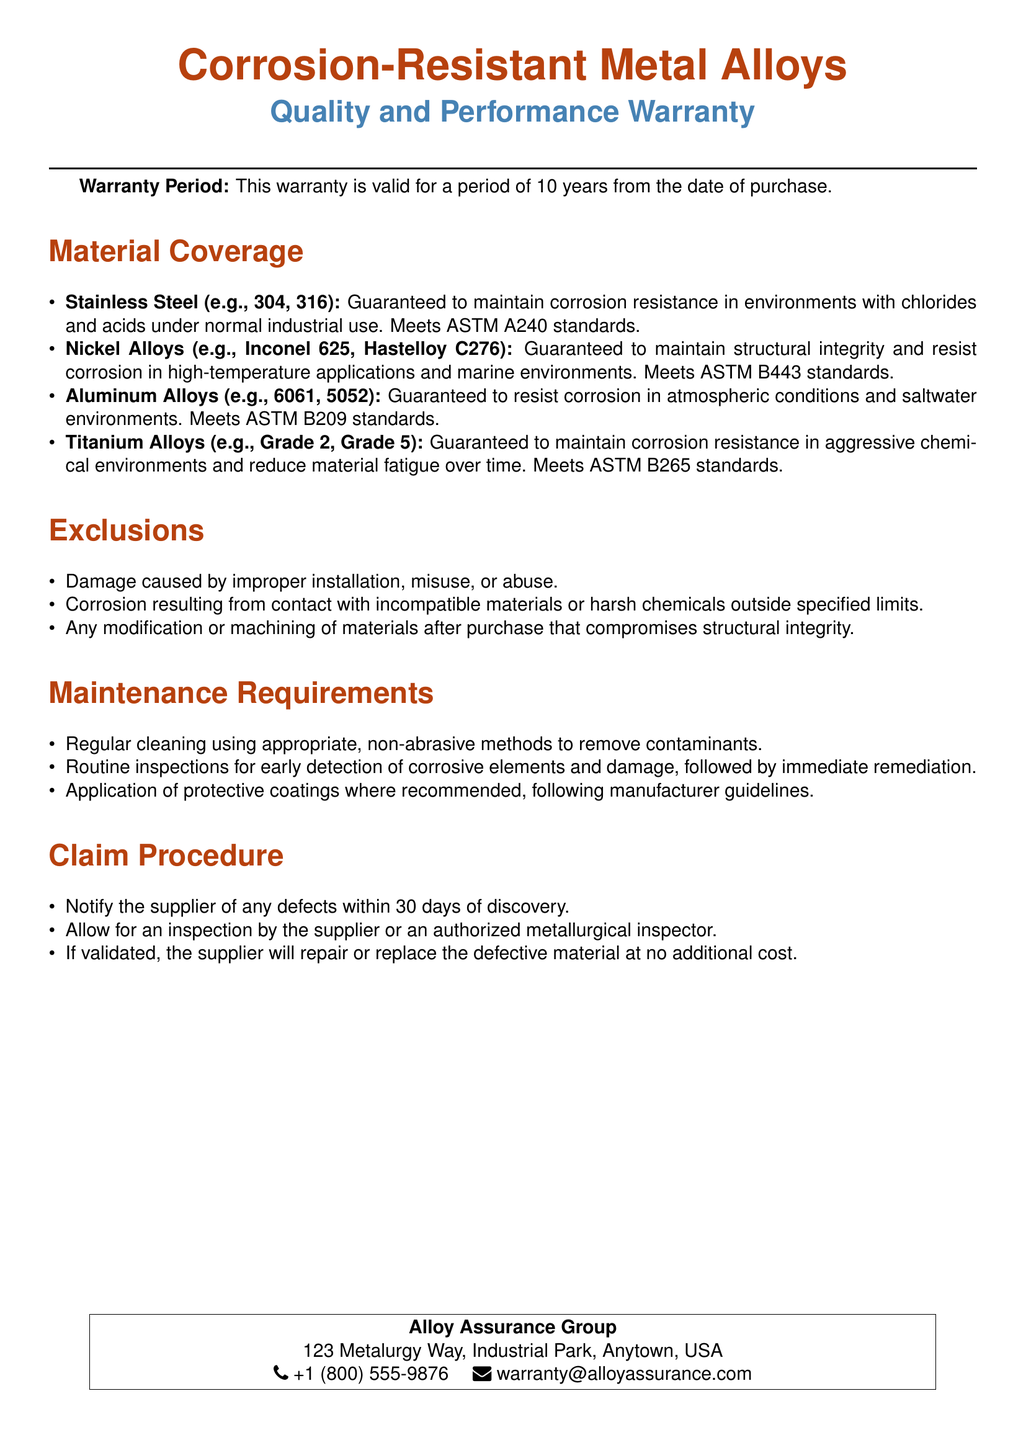What is the warranty period for corrosion-resistant metal alloys? The warranty period is stated as valid for a period from the date of purchase.
Answer: 10 years Which stainless steel grades are covered under the warranty? The document lists specific grades of stainless steel that are covered.
Answer: 304, 316 What is a requirement for maintaining warranty validity? The warranty includes stipulations on what is required to maintain its validity.
Answer: Regular cleaning What happens if defects are discovered? There are specific steps outlined for what should be done concerning defects.
Answer: Notify the supplier What materials are excluded from the warranty? The document states specific conditions that, if met, will exclude coverage under the warranty.
Answer: Improper installation What standard do Aluminum Alloys need to meet? The warranty mentions specific standards for materials covered.
Answer: ASTM B209 Where should claims be directed in case of a defect? The document specifies a point of contact for warranty claims.
Answer: Alloy Assurance Group What is required immediately after detecting corrosive elements? The maintenance section covers actions that are required upon detection of issues.
Answer: Immediate remediation 